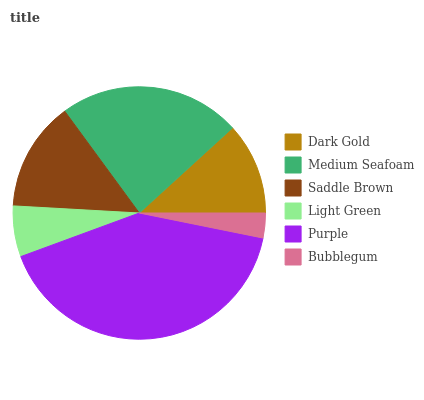Is Bubblegum the minimum?
Answer yes or no. Yes. Is Purple the maximum?
Answer yes or no. Yes. Is Medium Seafoam the minimum?
Answer yes or no. No. Is Medium Seafoam the maximum?
Answer yes or no. No. Is Medium Seafoam greater than Dark Gold?
Answer yes or no. Yes. Is Dark Gold less than Medium Seafoam?
Answer yes or no. Yes. Is Dark Gold greater than Medium Seafoam?
Answer yes or no. No. Is Medium Seafoam less than Dark Gold?
Answer yes or no. No. Is Saddle Brown the high median?
Answer yes or no. Yes. Is Dark Gold the low median?
Answer yes or no. Yes. Is Medium Seafoam the high median?
Answer yes or no. No. Is Medium Seafoam the low median?
Answer yes or no. No. 